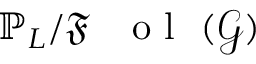<formula> <loc_0><loc_0><loc_500><loc_500>\mathbb { P } _ { L } / \mathfrak { F } { o l } ( \mathcal { G } )</formula> 